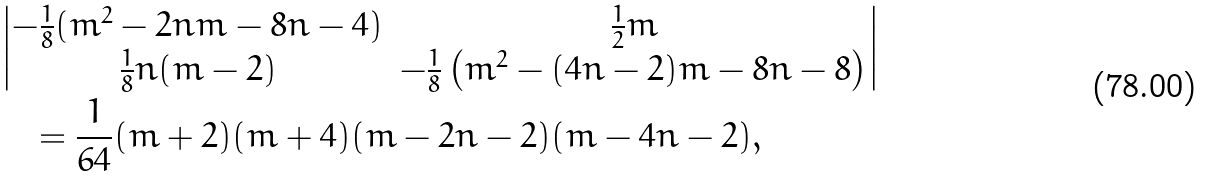<formula> <loc_0><loc_0><loc_500><loc_500>& \begin{vmatrix} - \frac { 1 } { 8 } ( m ^ { 2 } - 2 n m - 8 n - 4 ) & \frac { 1 } { 2 } m \\ \frac { 1 } { 8 } n ( m - 2 ) & - \frac { 1 } { 8 } \left ( m ^ { 2 } - ( 4 n - 2 ) m - 8 n - 8 \right ) \end{vmatrix} \\ & \quad = \frac { 1 } { 6 4 } ( m + 2 ) ( m + 4 ) ( m - 2 n - 2 ) ( m - 4 n - 2 ) ,</formula> 